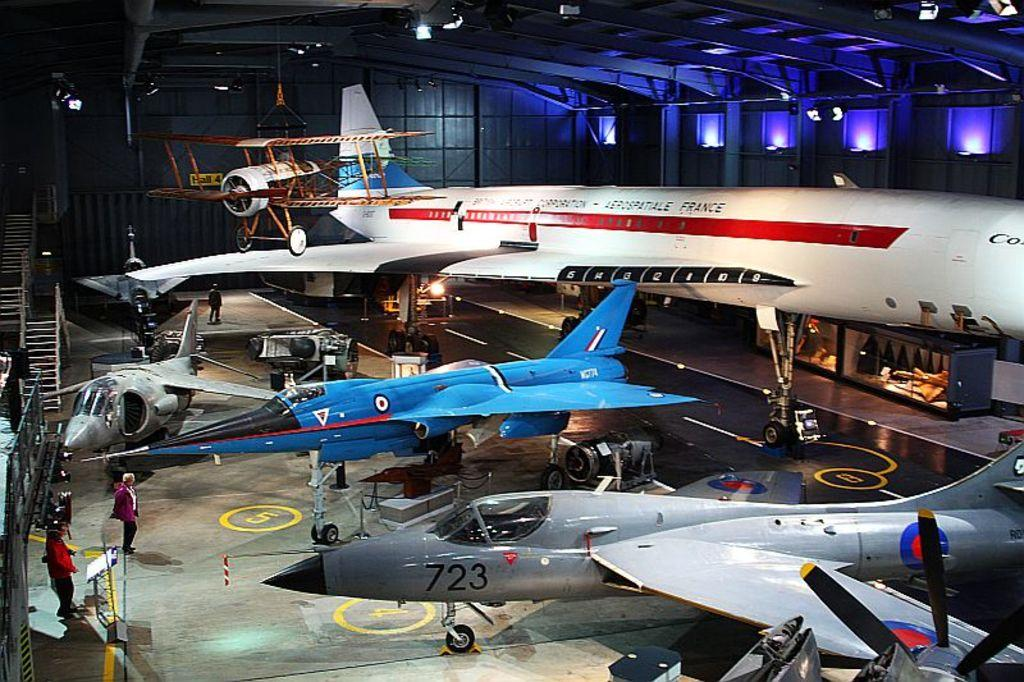Where is the image taken? The image is taken inside a shed. What is the main subject in the center of the image? There are aeroplanes in the center of the image. What can be seen on the left side of the image? There are people on the left side of the image. What feature is visible for accessing different levels in the image? There are stairs visible in the image. What is providing illumination at the top of the image? There are lights at the top of the image. What type of coat is the ant wearing in the image? There is no ant or coat present in the image. 